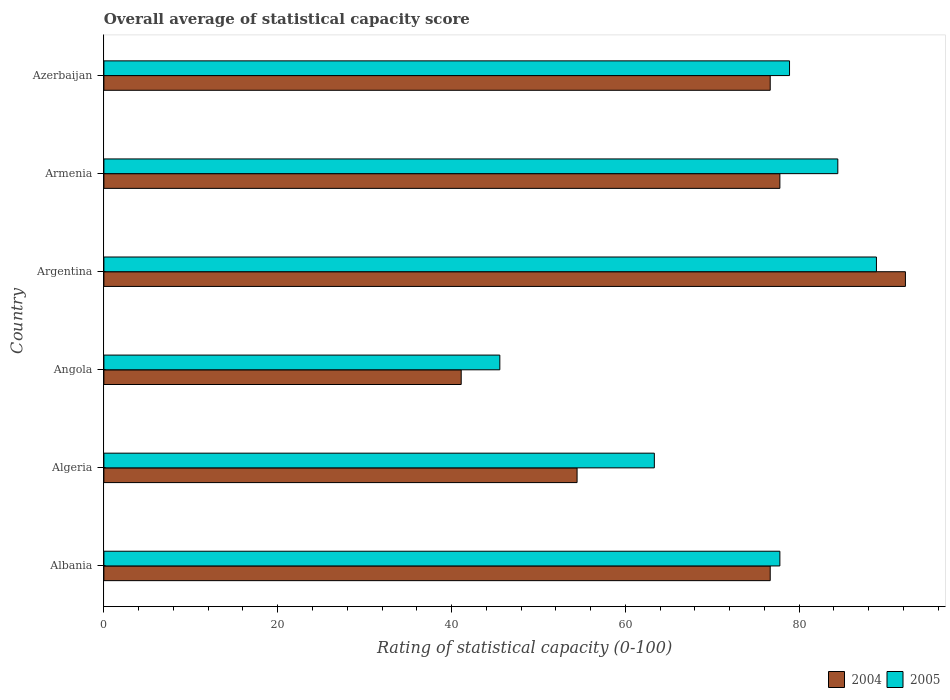How many different coloured bars are there?
Provide a succinct answer. 2. How many groups of bars are there?
Ensure brevity in your answer.  6. Are the number of bars per tick equal to the number of legend labels?
Offer a terse response. Yes. Are the number of bars on each tick of the Y-axis equal?
Offer a very short reply. Yes. How many bars are there on the 6th tick from the top?
Give a very brief answer. 2. What is the label of the 4th group of bars from the top?
Make the answer very short. Angola. In how many cases, is the number of bars for a given country not equal to the number of legend labels?
Ensure brevity in your answer.  0. What is the rating of statistical capacity in 2005 in Armenia?
Make the answer very short. 84.44. Across all countries, what is the maximum rating of statistical capacity in 2005?
Your response must be concise. 88.89. Across all countries, what is the minimum rating of statistical capacity in 2004?
Offer a very short reply. 41.11. In which country was the rating of statistical capacity in 2004 maximum?
Provide a short and direct response. Argentina. In which country was the rating of statistical capacity in 2005 minimum?
Provide a short and direct response. Angola. What is the total rating of statistical capacity in 2004 in the graph?
Your answer should be very brief. 418.89. What is the difference between the rating of statistical capacity in 2004 in Albania and that in Armenia?
Ensure brevity in your answer.  -1.11. What is the difference between the rating of statistical capacity in 2005 in Algeria and the rating of statistical capacity in 2004 in Azerbaijan?
Your answer should be very brief. -13.33. What is the average rating of statistical capacity in 2004 per country?
Offer a terse response. 69.81. What is the difference between the rating of statistical capacity in 2004 and rating of statistical capacity in 2005 in Armenia?
Provide a succinct answer. -6.67. In how many countries, is the rating of statistical capacity in 2004 greater than 12 ?
Your response must be concise. 6. What is the ratio of the rating of statistical capacity in 2005 in Angola to that in Armenia?
Offer a very short reply. 0.54. Is the rating of statistical capacity in 2005 in Albania less than that in Armenia?
Offer a very short reply. Yes. What is the difference between the highest and the second highest rating of statistical capacity in 2005?
Provide a succinct answer. 4.44. What is the difference between the highest and the lowest rating of statistical capacity in 2004?
Provide a short and direct response. 51.11. Is the sum of the rating of statistical capacity in 2004 in Angola and Argentina greater than the maximum rating of statistical capacity in 2005 across all countries?
Offer a terse response. Yes. What does the 2nd bar from the bottom in Argentina represents?
Your response must be concise. 2005. How many bars are there?
Your answer should be compact. 12. How many countries are there in the graph?
Your response must be concise. 6. What is the difference between two consecutive major ticks on the X-axis?
Give a very brief answer. 20. Does the graph contain any zero values?
Make the answer very short. No. Does the graph contain grids?
Your response must be concise. No. Where does the legend appear in the graph?
Make the answer very short. Bottom right. How are the legend labels stacked?
Give a very brief answer. Horizontal. What is the title of the graph?
Provide a succinct answer. Overall average of statistical capacity score. What is the label or title of the X-axis?
Give a very brief answer. Rating of statistical capacity (0-100). What is the label or title of the Y-axis?
Provide a succinct answer. Country. What is the Rating of statistical capacity (0-100) in 2004 in Albania?
Ensure brevity in your answer.  76.67. What is the Rating of statistical capacity (0-100) of 2005 in Albania?
Offer a terse response. 77.78. What is the Rating of statistical capacity (0-100) of 2004 in Algeria?
Your answer should be very brief. 54.44. What is the Rating of statistical capacity (0-100) in 2005 in Algeria?
Your response must be concise. 63.33. What is the Rating of statistical capacity (0-100) in 2004 in Angola?
Give a very brief answer. 41.11. What is the Rating of statistical capacity (0-100) in 2005 in Angola?
Offer a terse response. 45.56. What is the Rating of statistical capacity (0-100) in 2004 in Argentina?
Provide a succinct answer. 92.22. What is the Rating of statistical capacity (0-100) of 2005 in Argentina?
Provide a short and direct response. 88.89. What is the Rating of statistical capacity (0-100) of 2004 in Armenia?
Provide a succinct answer. 77.78. What is the Rating of statistical capacity (0-100) of 2005 in Armenia?
Your answer should be compact. 84.44. What is the Rating of statistical capacity (0-100) of 2004 in Azerbaijan?
Keep it short and to the point. 76.67. What is the Rating of statistical capacity (0-100) in 2005 in Azerbaijan?
Your response must be concise. 78.89. Across all countries, what is the maximum Rating of statistical capacity (0-100) in 2004?
Your answer should be compact. 92.22. Across all countries, what is the maximum Rating of statistical capacity (0-100) in 2005?
Your answer should be very brief. 88.89. Across all countries, what is the minimum Rating of statistical capacity (0-100) of 2004?
Your answer should be compact. 41.11. Across all countries, what is the minimum Rating of statistical capacity (0-100) in 2005?
Your answer should be very brief. 45.56. What is the total Rating of statistical capacity (0-100) in 2004 in the graph?
Ensure brevity in your answer.  418.89. What is the total Rating of statistical capacity (0-100) of 2005 in the graph?
Ensure brevity in your answer.  438.89. What is the difference between the Rating of statistical capacity (0-100) in 2004 in Albania and that in Algeria?
Provide a short and direct response. 22.22. What is the difference between the Rating of statistical capacity (0-100) in 2005 in Albania and that in Algeria?
Provide a succinct answer. 14.44. What is the difference between the Rating of statistical capacity (0-100) in 2004 in Albania and that in Angola?
Provide a succinct answer. 35.56. What is the difference between the Rating of statistical capacity (0-100) in 2005 in Albania and that in Angola?
Offer a very short reply. 32.22. What is the difference between the Rating of statistical capacity (0-100) in 2004 in Albania and that in Argentina?
Keep it short and to the point. -15.56. What is the difference between the Rating of statistical capacity (0-100) of 2005 in Albania and that in Argentina?
Offer a terse response. -11.11. What is the difference between the Rating of statistical capacity (0-100) in 2004 in Albania and that in Armenia?
Give a very brief answer. -1.11. What is the difference between the Rating of statistical capacity (0-100) of 2005 in Albania and that in Armenia?
Your answer should be compact. -6.67. What is the difference between the Rating of statistical capacity (0-100) in 2005 in Albania and that in Azerbaijan?
Your answer should be very brief. -1.11. What is the difference between the Rating of statistical capacity (0-100) of 2004 in Algeria and that in Angola?
Your answer should be very brief. 13.33. What is the difference between the Rating of statistical capacity (0-100) of 2005 in Algeria and that in Angola?
Offer a terse response. 17.78. What is the difference between the Rating of statistical capacity (0-100) in 2004 in Algeria and that in Argentina?
Provide a succinct answer. -37.78. What is the difference between the Rating of statistical capacity (0-100) in 2005 in Algeria and that in Argentina?
Keep it short and to the point. -25.56. What is the difference between the Rating of statistical capacity (0-100) of 2004 in Algeria and that in Armenia?
Ensure brevity in your answer.  -23.33. What is the difference between the Rating of statistical capacity (0-100) of 2005 in Algeria and that in Armenia?
Make the answer very short. -21.11. What is the difference between the Rating of statistical capacity (0-100) of 2004 in Algeria and that in Azerbaijan?
Make the answer very short. -22.22. What is the difference between the Rating of statistical capacity (0-100) in 2005 in Algeria and that in Azerbaijan?
Make the answer very short. -15.56. What is the difference between the Rating of statistical capacity (0-100) of 2004 in Angola and that in Argentina?
Keep it short and to the point. -51.11. What is the difference between the Rating of statistical capacity (0-100) in 2005 in Angola and that in Argentina?
Offer a very short reply. -43.33. What is the difference between the Rating of statistical capacity (0-100) of 2004 in Angola and that in Armenia?
Your answer should be very brief. -36.67. What is the difference between the Rating of statistical capacity (0-100) of 2005 in Angola and that in Armenia?
Provide a succinct answer. -38.89. What is the difference between the Rating of statistical capacity (0-100) of 2004 in Angola and that in Azerbaijan?
Keep it short and to the point. -35.56. What is the difference between the Rating of statistical capacity (0-100) of 2005 in Angola and that in Azerbaijan?
Your response must be concise. -33.33. What is the difference between the Rating of statistical capacity (0-100) of 2004 in Argentina and that in Armenia?
Make the answer very short. 14.44. What is the difference between the Rating of statistical capacity (0-100) of 2005 in Argentina and that in Armenia?
Your answer should be compact. 4.44. What is the difference between the Rating of statistical capacity (0-100) in 2004 in Argentina and that in Azerbaijan?
Make the answer very short. 15.56. What is the difference between the Rating of statistical capacity (0-100) of 2004 in Armenia and that in Azerbaijan?
Ensure brevity in your answer.  1.11. What is the difference between the Rating of statistical capacity (0-100) of 2005 in Armenia and that in Azerbaijan?
Provide a succinct answer. 5.56. What is the difference between the Rating of statistical capacity (0-100) of 2004 in Albania and the Rating of statistical capacity (0-100) of 2005 in Algeria?
Give a very brief answer. 13.33. What is the difference between the Rating of statistical capacity (0-100) in 2004 in Albania and the Rating of statistical capacity (0-100) in 2005 in Angola?
Offer a terse response. 31.11. What is the difference between the Rating of statistical capacity (0-100) of 2004 in Albania and the Rating of statistical capacity (0-100) of 2005 in Argentina?
Ensure brevity in your answer.  -12.22. What is the difference between the Rating of statistical capacity (0-100) in 2004 in Albania and the Rating of statistical capacity (0-100) in 2005 in Armenia?
Keep it short and to the point. -7.78. What is the difference between the Rating of statistical capacity (0-100) of 2004 in Albania and the Rating of statistical capacity (0-100) of 2005 in Azerbaijan?
Your response must be concise. -2.22. What is the difference between the Rating of statistical capacity (0-100) in 2004 in Algeria and the Rating of statistical capacity (0-100) in 2005 in Angola?
Give a very brief answer. 8.89. What is the difference between the Rating of statistical capacity (0-100) of 2004 in Algeria and the Rating of statistical capacity (0-100) of 2005 in Argentina?
Ensure brevity in your answer.  -34.44. What is the difference between the Rating of statistical capacity (0-100) in 2004 in Algeria and the Rating of statistical capacity (0-100) in 2005 in Azerbaijan?
Offer a very short reply. -24.44. What is the difference between the Rating of statistical capacity (0-100) in 2004 in Angola and the Rating of statistical capacity (0-100) in 2005 in Argentina?
Offer a terse response. -47.78. What is the difference between the Rating of statistical capacity (0-100) of 2004 in Angola and the Rating of statistical capacity (0-100) of 2005 in Armenia?
Give a very brief answer. -43.33. What is the difference between the Rating of statistical capacity (0-100) in 2004 in Angola and the Rating of statistical capacity (0-100) in 2005 in Azerbaijan?
Offer a very short reply. -37.78. What is the difference between the Rating of statistical capacity (0-100) in 2004 in Argentina and the Rating of statistical capacity (0-100) in 2005 in Armenia?
Keep it short and to the point. 7.78. What is the difference between the Rating of statistical capacity (0-100) of 2004 in Argentina and the Rating of statistical capacity (0-100) of 2005 in Azerbaijan?
Provide a short and direct response. 13.33. What is the difference between the Rating of statistical capacity (0-100) of 2004 in Armenia and the Rating of statistical capacity (0-100) of 2005 in Azerbaijan?
Your answer should be compact. -1.11. What is the average Rating of statistical capacity (0-100) of 2004 per country?
Your response must be concise. 69.81. What is the average Rating of statistical capacity (0-100) in 2005 per country?
Provide a short and direct response. 73.15. What is the difference between the Rating of statistical capacity (0-100) of 2004 and Rating of statistical capacity (0-100) of 2005 in Albania?
Offer a terse response. -1.11. What is the difference between the Rating of statistical capacity (0-100) of 2004 and Rating of statistical capacity (0-100) of 2005 in Algeria?
Your response must be concise. -8.89. What is the difference between the Rating of statistical capacity (0-100) in 2004 and Rating of statistical capacity (0-100) in 2005 in Angola?
Offer a terse response. -4.44. What is the difference between the Rating of statistical capacity (0-100) of 2004 and Rating of statistical capacity (0-100) of 2005 in Armenia?
Provide a succinct answer. -6.67. What is the difference between the Rating of statistical capacity (0-100) in 2004 and Rating of statistical capacity (0-100) in 2005 in Azerbaijan?
Give a very brief answer. -2.22. What is the ratio of the Rating of statistical capacity (0-100) of 2004 in Albania to that in Algeria?
Your answer should be very brief. 1.41. What is the ratio of the Rating of statistical capacity (0-100) of 2005 in Albania to that in Algeria?
Your answer should be very brief. 1.23. What is the ratio of the Rating of statistical capacity (0-100) of 2004 in Albania to that in Angola?
Ensure brevity in your answer.  1.86. What is the ratio of the Rating of statistical capacity (0-100) of 2005 in Albania to that in Angola?
Your answer should be compact. 1.71. What is the ratio of the Rating of statistical capacity (0-100) in 2004 in Albania to that in Argentina?
Your answer should be very brief. 0.83. What is the ratio of the Rating of statistical capacity (0-100) of 2004 in Albania to that in Armenia?
Keep it short and to the point. 0.99. What is the ratio of the Rating of statistical capacity (0-100) in 2005 in Albania to that in Armenia?
Give a very brief answer. 0.92. What is the ratio of the Rating of statistical capacity (0-100) of 2005 in Albania to that in Azerbaijan?
Offer a terse response. 0.99. What is the ratio of the Rating of statistical capacity (0-100) in 2004 in Algeria to that in Angola?
Make the answer very short. 1.32. What is the ratio of the Rating of statistical capacity (0-100) of 2005 in Algeria to that in Angola?
Keep it short and to the point. 1.39. What is the ratio of the Rating of statistical capacity (0-100) of 2004 in Algeria to that in Argentina?
Keep it short and to the point. 0.59. What is the ratio of the Rating of statistical capacity (0-100) of 2005 in Algeria to that in Argentina?
Ensure brevity in your answer.  0.71. What is the ratio of the Rating of statistical capacity (0-100) in 2004 in Algeria to that in Armenia?
Offer a very short reply. 0.7. What is the ratio of the Rating of statistical capacity (0-100) in 2005 in Algeria to that in Armenia?
Your answer should be very brief. 0.75. What is the ratio of the Rating of statistical capacity (0-100) of 2004 in Algeria to that in Azerbaijan?
Keep it short and to the point. 0.71. What is the ratio of the Rating of statistical capacity (0-100) of 2005 in Algeria to that in Azerbaijan?
Offer a very short reply. 0.8. What is the ratio of the Rating of statistical capacity (0-100) of 2004 in Angola to that in Argentina?
Your answer should be compact. 0.45. What is the ratio of the Rating of statistical capacity (0-100) in 2005 in Angola to that in Argentina?
Your answer should be compact. 0.51. What is the ratio of the Rating of statistical capacity (0-100) in 2004 in Angola to that in Armenia?
Your answer should be very brief. 0.53. What is the ratio of the Rating of statistical capacity (0-100) of 2005 in Angola to that in Armenia?
Ensure brevity in your answer.  0.54. What is the ratio of the Rating of statistical capacity (0-100) of 2004 in Angola to that in Azerbaijan?
Your answer should be compact. 0.54. What is the ratio of the Rating of statistical capacity (0-100) of 2005 in Angola to that in Azerbaijan?
Offer a very short reply. 0.58. What is the ratio of the Rating of statistical capacity (0-100) in 2004 in Argentina to that in Armenia?
Keep it short and to the point. 1.19. What is the ratio of the Rating of statistical capacity (0-100) of 2005 in Argentina to that in Armenia?
Provide a short and direct response. 1.05. What is the ratio of the Rating of statistical capacity (0-100) in 2004 in Argentina to that in Azerbaijan?
Give a very brief answer. 1.2. What is the ratio of the Rating of statistical capacity (0-100) in 2005 in Argentina to that in Azerbaijan?
Your response must be concise. 1.13. What is the ratio of the Rating of statistical capacity (0-100) in 2004 in Armenia to that in Azerbaijan?
Offer a very short reply. 1.01. What is the ratio of the Rating of statistical capacity (0-100) of 2005 in Armenia to that in Azerbaijan?
Your answer should be compact. 1.07. What is the difference between the highest and the second highest Rating of statistical capacity (0-100) of 2004?
Offer a very short reply. 14.44. What is the difference between the highest and the second highest Rating of statistical capacity (0-100) of 2005?
Give a very brief answer. 4.44. What is the difference between the highest and the lowest Rating of statistical capacity (0-100) of 2004?
Your response must be concise. 51.11. What is the difference between the highest and the lowest Rating of statistical capacity (0-100) of 2005?
Provide a short and direct response. 43.33. 